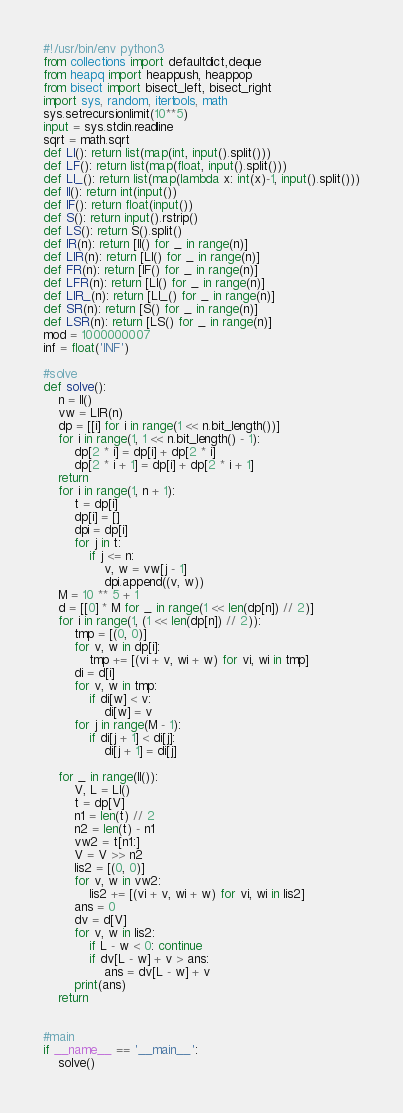Convert code to text. <code><loc_0><loc_0><loc_500><loc_500><_Python_>#!/usr/bin/env python3
from collections import defaultdict,deque
from heapq import heappush, heappop
from bisect import bisect_left, bisect_right
import sys, random, itertools, math
sys.setrecursionlimit(10**5)
input = sys.stdin.readline
sqrt = math.sqrt
def LI(): return list(map(int, input().split()))
def LF(): return list(map(float, input().split()))
def LI_(): return list(map(lambda x: int(x)-1, input().split()))
def II(): return int(input())
def IF(): return float(input())
def S(): return input().rstrip()
def LS(): return S().split()
def IR(n): return [II() for _ in range(n)]
def LIR(n): return [LI() for _ in range(n)]
def FR(n): return [IF() for _ in range(n)]
def LFR(n): return [LI() for _ in range(n)]
def LIR_(n): return [LI_() for _ in range(n)]
def SR(n): return [S() for _ in range(n)]
def LSR(n): return [LS() for _ in range(n)]
mod = 1000000007
inf = float('INF')

#solve
def solve():
    n = II()
    vw = LIR(n)
    dp = [[i] for i in range(1 << n.bit_length())]
    for i in range(1, 1 << n.bit_length() - 1):
        dp[2 * i] = dp[i] + dp[2 * i]
        dp[2 * i + 1] = dp[i] + dp[2 * i + 1]
    return
    for i in range(1, n + 1):
        t = dp[i]
        dp[i] = []
        dpi = dp[i]
        for j in t:
            if j <= n:
                v, w = vw[j - 1]
                dpi.append((v, w))
    M = 10 ** 5 + 1
    d = [[0] * M for _ in range(1 << len(dp[n]) // 2)]
    for i in range(1, (1 << len(dp[n]) // 2)):
        tmp = [(0, 0)]
        for v, w in dp[i]:
            tmp += [(vi + v, wi + w) for vi, wi in tmp]
        di = d[i]
        for v, w in tmp:
            if di[w] < v:
                di[w] = v
        for j in range(M - 1):
            if di[j + 1] < di[j]:
                di[j + 1] = di[j] 
                
    for _ in range(II()):
        V, L = LI()
        t = dp[V]
        n1 = len(t) // 2
        n2 = len(t) - n1
        vw2 = t[n1:]
        V = V >> n2
        lis2 = [(0, 0)]
        for v, w in vw2:
            lis2 += [(vi + v, wi + w) for vi, wi in lis2]
        ans = 0
        dv = d[V]
        for v, w in lis2:
            if L - w < 0: continue
            if dv[L - w] + v > ans:
                ans = dv[L - w] + v
        print(ans)
    return


#main
if __name__ == '__main__':
    solve()
</code> 